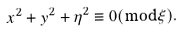<formula> <loc_0><loc_0><loc_500><loc_500>x ^ { 2 } + y ^ { 2 } + \eta ^ { 2 } \equiv 0 ( \bmod \xi ) .</formula> 